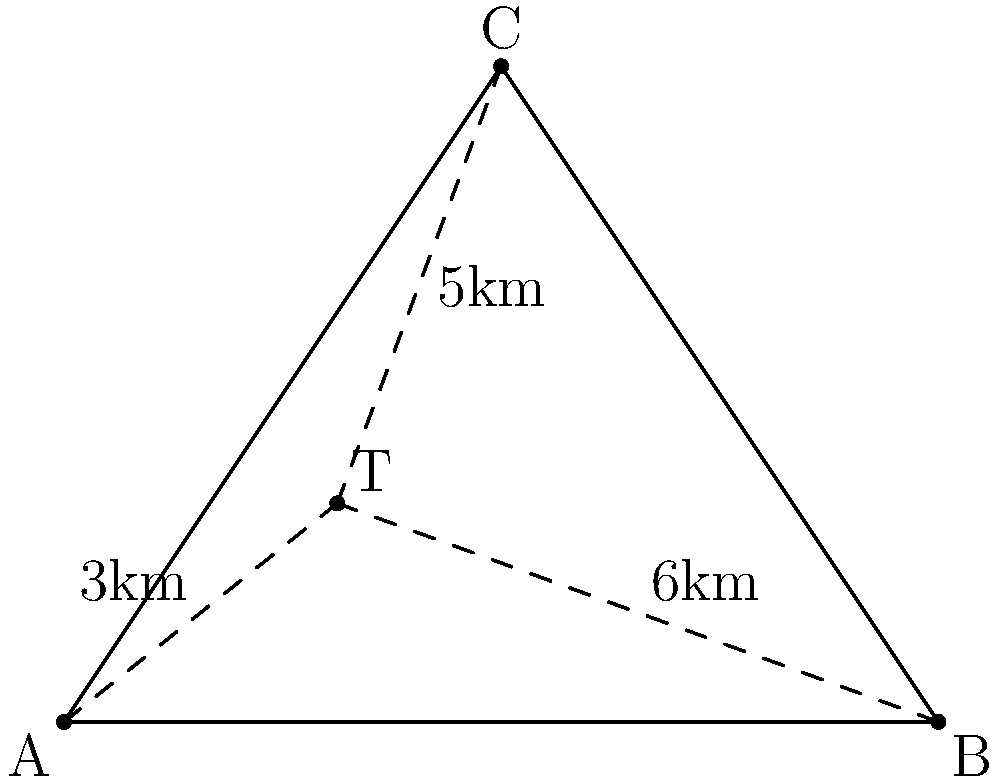Three cities A, B, and C form a triangle as shown in the diagram. A 5G tower (T) needs to be placed to provide optimal coverage. Given that the distances from the tower to cities A, B, and C are 3km, 6km, and 5km respectively, what is the area of triangle ABC in square kilometers? To find the area of triangle ABC, we can use Heron's formula. But first, we need to find the lengths of the sides of the triangle.

Step 1: Use the distance formula to find AB, BC, and AC.
Let's set up a coordinate system where A is at (0,0), B at (8,0), and C at (4,6).

$AB = 8$ km (given by the x-coordinate of B)

$BC = \sqrt{(4-8)^2 + (6-0)^2} = \sqrt{16 + 36} = \sqrt{52} = 2\sqrt{13}$ km

$AC = \sqrt{4^2 + 6^2} = \sqrt{16 + 36} = \sqrt{52} = 2\sqrt{13}$ km

Step 2: Apply Heron's formula
Heron's formula states that the area of a triangle with sides a, b, and c is:

$Area = \sqrt{s(s-a)(s-b)(s-c)}$

where $s = \frac{a+b+c}{2}$ (half-perimeter)

$s = \frac{8 + 2\sqrt{13} + 2\sqrt{13}}{2} = 4 + \sqrt{13}$

Now, let's substitute into Heron's formula:

$Area = \sqrt{(4+\sqrt{13})(4+\sqrt{13}-8)(4+\sqrt{13}-2\sqrt{13})(4+\sqrt{13}-2\sqrt{13})}$

$= \sqrt{(4+\sqrt{13})(-4+\sqrt{13})(4)(4)}$

$= \sqrt{(16-13)(16)} = \sqrt{48} = 4\sqrt{3}$

Therefore, the area of triangle ABC is $4\sqrt{3}$ square kilometers.
Answer: $4\sqrt{3}$ sq km 